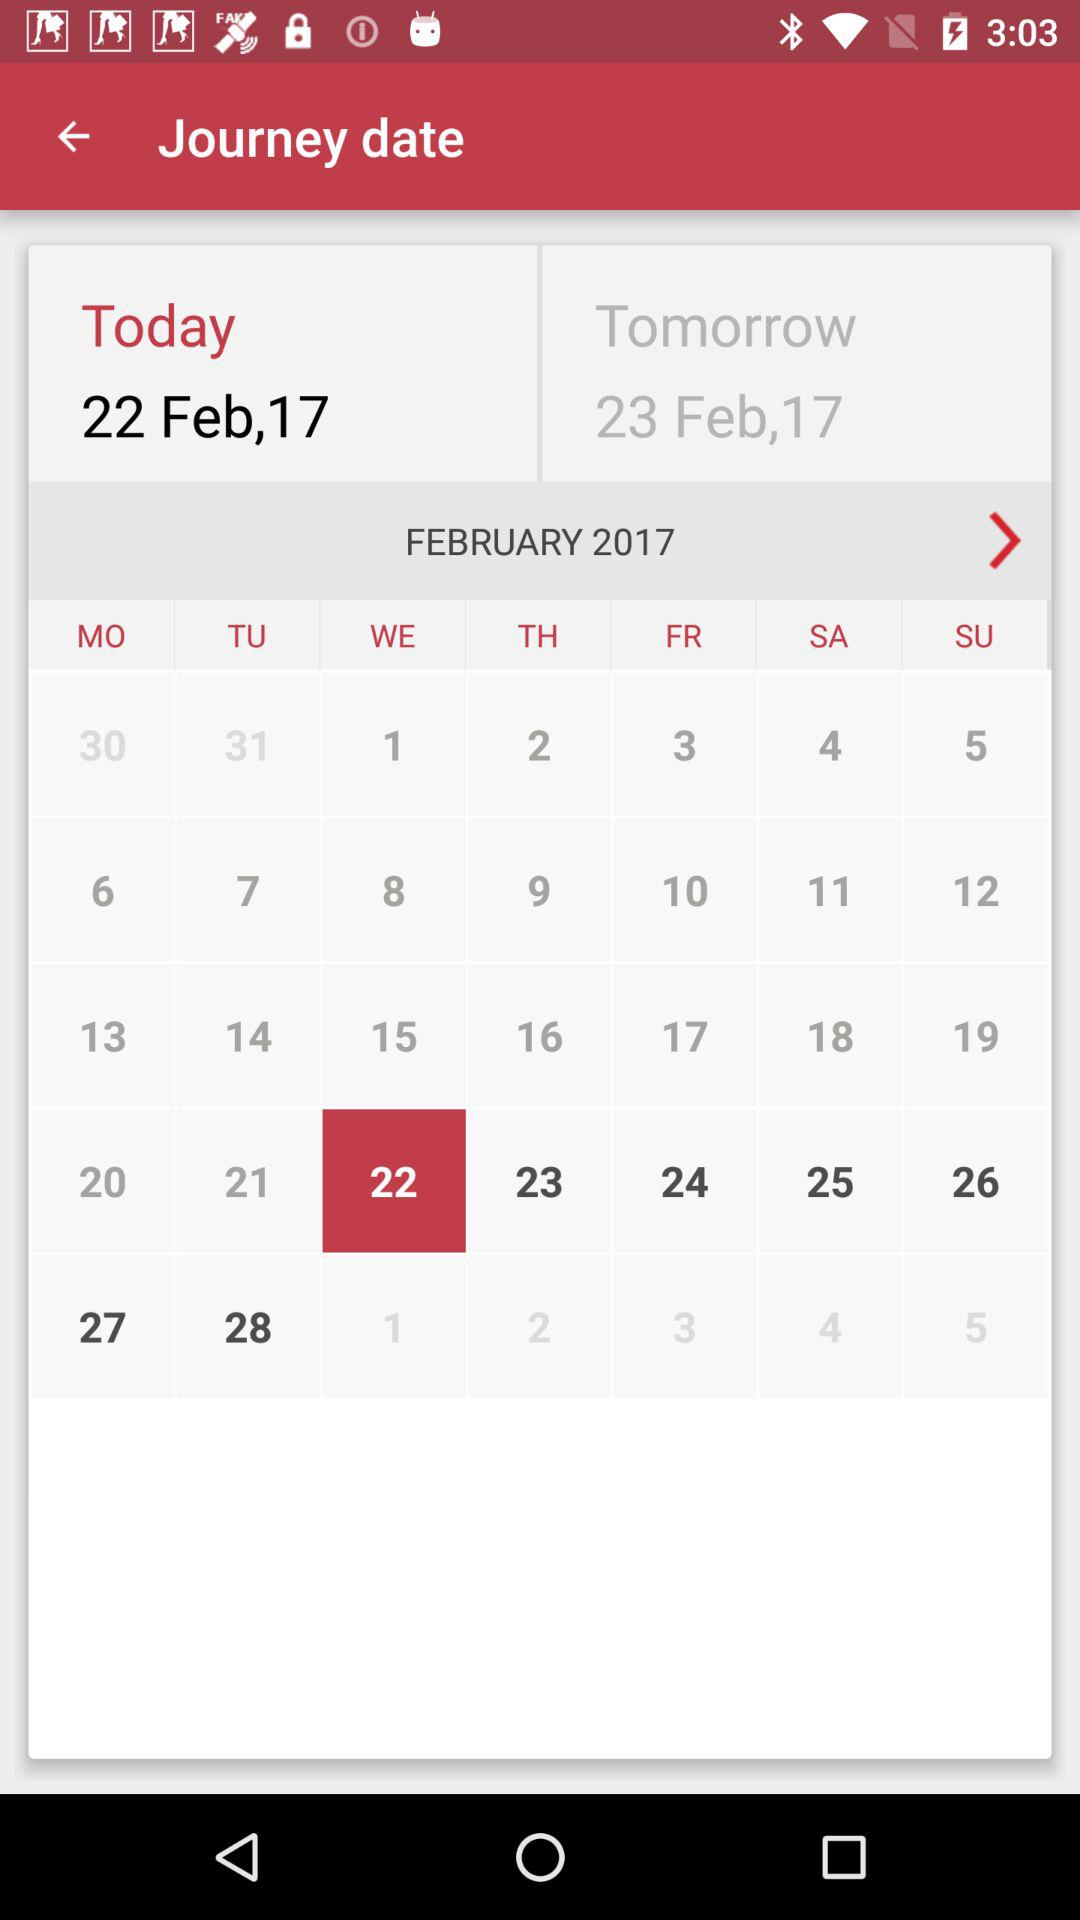What is the date for tomorrow? The date is February 23, 2017. 